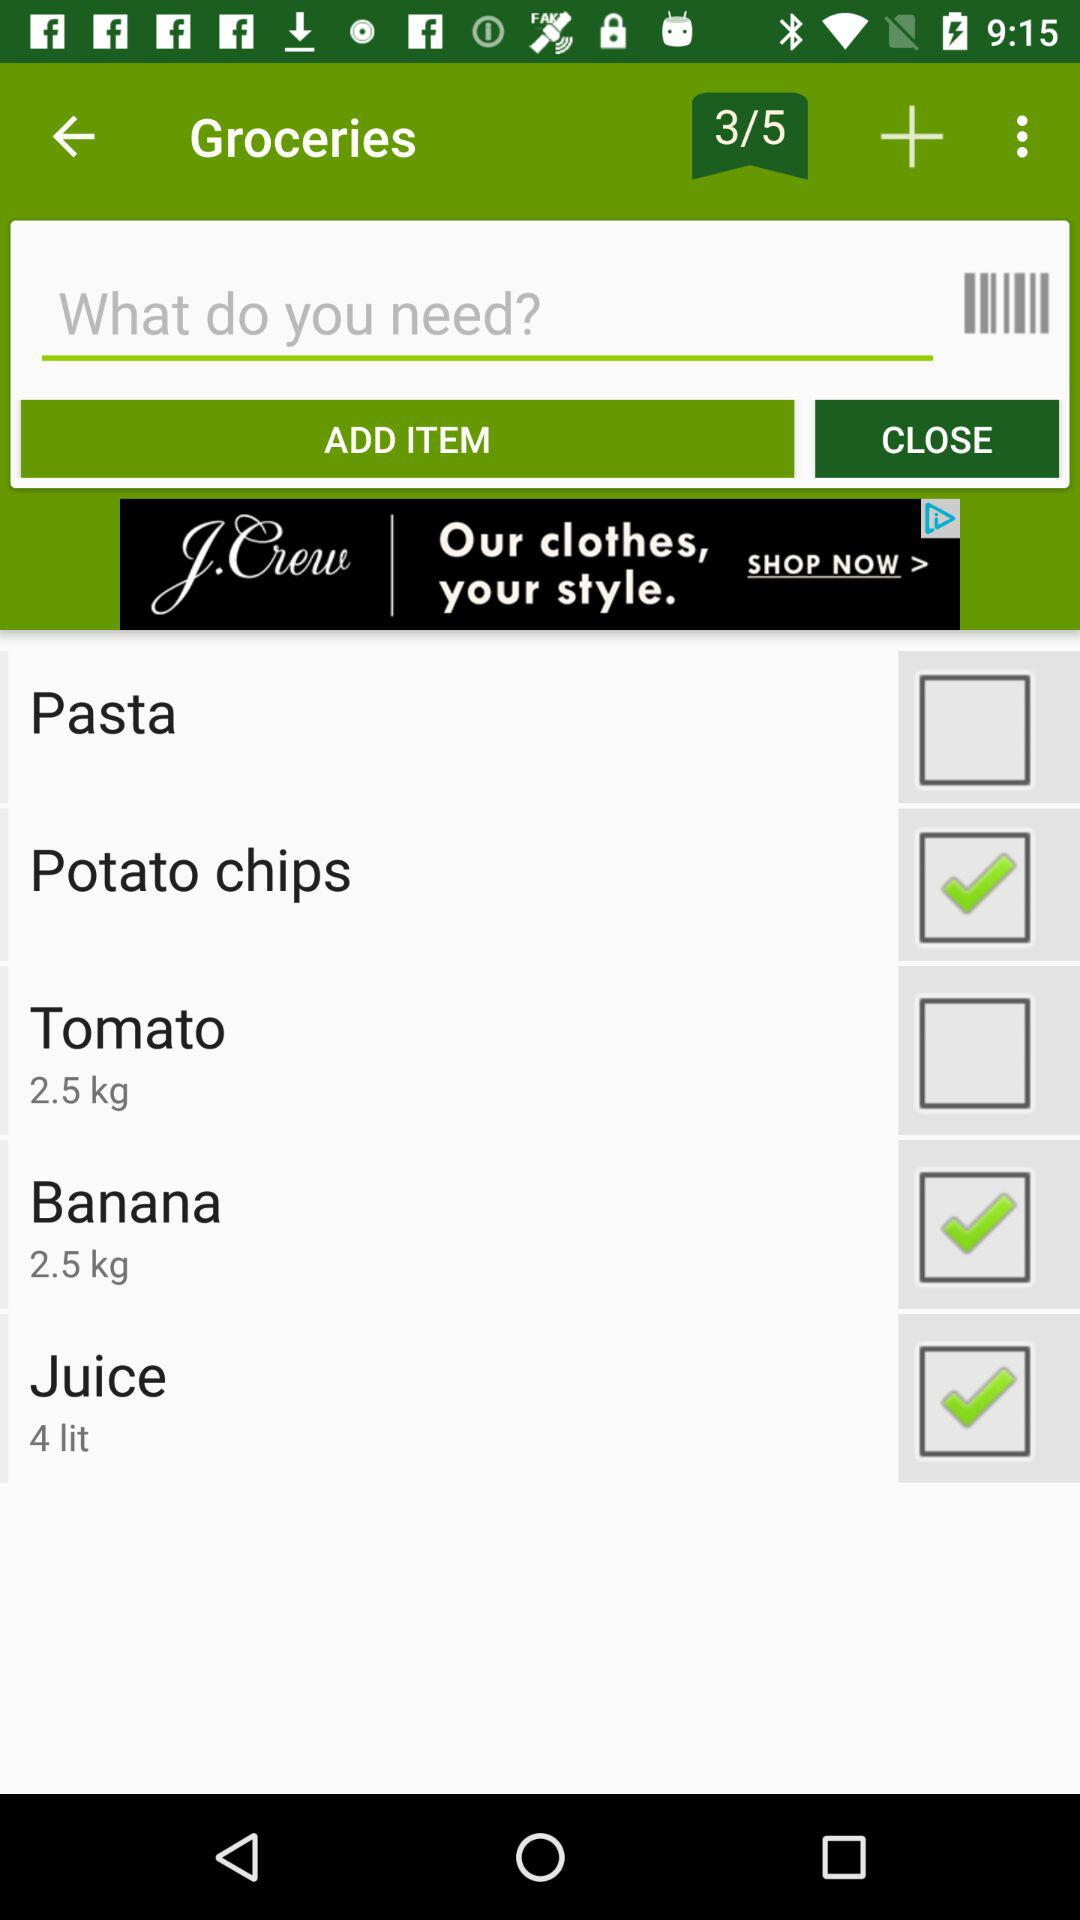How many items have been selected? There are 3 items selected. 